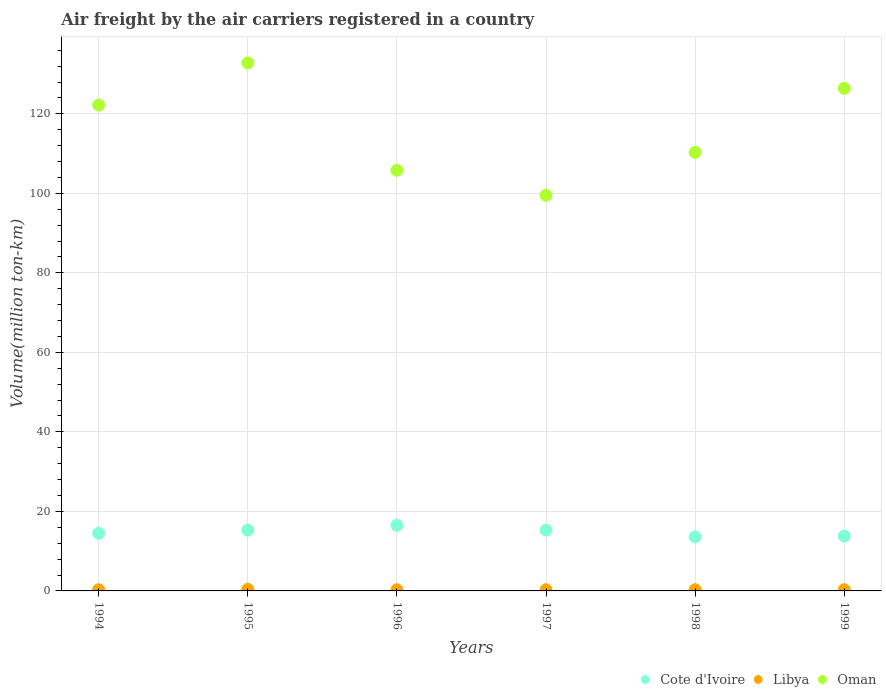Is the number of dotlines equal to the number of legend labels?
Your response must be concise. Yes. What is the volume of the air carriers in Oman in 1995?
Make the answer very short. 132.8. Across all years, what is the minimum volume of the air carriers in Oman?
Ensure brevity in your answer.  99.5. In which year was the volume of the air carriers in Libya maximum?
Your answer should be very brief. 1995. What is the total volume of the air carriers in Libya in the graph?
Give a very brief answer. 1.9. What is the difference between the volume of the air carriers in Cote d'Ivoire in 1994 and the volume of the air carriers in Libya in 1999?
Give a very brief answer. 14.2. What is the average volume of the air carriers in Cote d'Ivoire per year?
Your answer should be compact. 14.83. In the year 1998, what is the difference between the volume of the air carriers in Libya and volume of the air carriers in Cote d'Ivoire?
Ensure brevity in your answer.  -13.3. In how many years, is the volume of the air carriers in Libya greater than 92 million ton-km?
Give a very brief answer. 0. What is the ratio of the volume of the air carriers in Cote d'Ivoire in 1997 to that in 1998?
Your answer should be very brief. 1.12. Is the difference between the volume of the air carriers in Libya in 1995 and 1999 greater than the difference between the volume of the air carriers in Cote d'Ivoire in 1995 and 1999?
Offer a very short reply. No. What is the difference between the highest and the second highest volume of the air carriers in Libya?
Your answer should be compact. 0.1. What is the difference between the highest and the lowest volume of the air carriers in Libya?
Keep it short and to the point. 0.1. Is the sum of the volume of the air carriers in Oman in 1995 and 1998 greater than the maximum volume of the air carriers in Libya across all years?
Your response must be concise. Yes. Is it the case that in every year, the sum of the volume of the air carriers in Oman and volume of the air carriers in Cote d'Ivoire  is greater than the volume of the air carriers in Libya?
Provide a succinct answer. Yes. Is the volume of the air carriers in Cote d'Ivoire strictly greater than the volume of the air carriers in Libya over the years?
Offer a terse response. Yes. Is the volume of the air carriers in Libya strictly less than the volume of the air carriers in Oman over the years?
Your answer should be very brief. Yes. How many years are there in the graph?
Provide a short and direct response. 6. What is the difference between two consecutive major ticks on the Y-axis?
Your answer should be compact. 20. Does the graph contain any zero values?
Your answer should be compact. No. Does the graph contain grids?
Provide a short and direct response. Yes. Where does the legend appear in the graph?
Provide a succinct answer. Bottom right. How are the legend labels stacked?
Keep it short and to the point. Horizontal. What is the title of the graph?
Offer a terse response. Air freight by the air carriers registered in a country. What is the label or title of the X-axis?
Make the answer very short. Years. What is the label or title of the Y-axis?
Your answer should be very brief. Volume(million ton-km). What is the Volume(million ton-km) in Cote d'Ivoire in 1994?
Ensure brevity in your answer.  14.5. What is the Volume(million ton-km) of Libya in 1994?
Provide a succinct answer. 0.3. What is the Volume(million ton-km) of Oman in 1994?
Ensure brevity in your answer.  122.2. What is the Volume(million ton-km) of Cote d'Ivoire in 1995?
Your answer should be compact. 15.3. What is the Volume(million ton-km) in Libya in 1995?
Offer a very short reply. 0.4. What is the Volume(million ton-km) in Oman in 1995?
Ensure brevity in your answer.  132.8. What is the Volume(million ton-km) of Libya in 1996?
Your response must be concise. 0.3. What is the Volume(million ton-km) of Oman in 1996?
Your answer should be compact. 105.8. What is the Volume(million ton-km) of Cote d'Ivoire in 1997?
Offer a very short reply. 15.3. What is the Volume(million ton-km) of Libya in 1997?
Offer a terse response. 0.3. What is the Volume(million ton-km) of Oman in 1997?
Make the answer very short. 99.5. What is the Volume(million ton-km) of Cote d'Ivoire in 1998?
Your answer should be compact. 13.6. What is the Volume(million ton-km) of Libya in 1998?
Provide a succinct answer. 0.3. What is the Volume(million ton-km) in Oman in 1998?
Offer a very short reply. 110.3. What is the Volume(million ton-km) in Cote d'Ivoire in 1999?
Offer a very short reply. 13.8. What is the Volume(million ton-km) of Libya in 1999?
Your response must be concise. 0.3. What is the Volume(million ton-km) in Oman in 1999?
Make the answer very short. 126.4. Across all years, what is the maximum Volume(million ton-km) of Libya?
Your answer should be compact. 0.4. Across all years, what is the maximum Volume(million ton-km) in Oman?
Offer a very short reply. 132.8. Across all years, what is the minimum Volume(million ton-km) of Cote d'Ivoire?
Ensure brevity in your answer.  13.6. Across all years, what is the minimum Volume(million ton-km) in Libya?
Your answer should be very brief. 0.3. Across all years, what is the minimum Volume(million ton-km) of Oman?
Your response must be concise. 99.5. What is the total Volume(million ton-km) of Cote d'Ivoire in the graph?
Provide a succinct answer. 89. What is the total Volume(million ton-km) in Oman in the graph?
Provide a short and direct response. 697. What is the difference between the Volume(million ton-km) of Cote d'Ivoire in 1994 and that in 1995?
Ensure brevity in your answer.  -0.8. What is the difference between the Volume(million ton-km) of Libya in 1994 and that in 1995?
Make the answer very short. -0.1. What is the difference between the Volume(million ton-km) of Oman in 1994 and that in 1995?
Your response must be concise. -10.6. What is the difference between the Volume(million ton-km) in Libya in 1994 and that in 1996?
Give a very brief answer. 0. What is the difference between the Volume(million ton-km) in Oman in 1994 and that in 1996?
Your answer should be very brief. 16.4. What is the difference between the Volume(million ton-km) of Cote d'Ivoire in 1994 and that in 1997?
Offer a terse response. -0.8. What is the difference between the Volume(million ton-km) of Libya in 1994 and that in 1997?
Give a very brief answer. 0. What is the difference between the Volume(million ton-km) in Oman in 1994 and that in 1997?
Keep it short and to the point. 22.7. What is the difference between the Volume(million ton-km) in Oman in 1994 and that in 1998?
Give a very brief answer. 11.9. What is the difference between the Volume(million ton-km) in Cote d'Ivoire in 1994 and that in 1999?
Your response must be concise. 0.7. What is the difference between the Volume(million ton-km) in Oman in 1994 and that in 1999?
Make the answer very short. -4.2. What is the difference between the Volume(million ton-km) of Libya in 1995 and that in 1996?
Ensure brevity in your answer.  0.1. What is the difference between the Volume(million ton-km) in Libya in 1995 and that in 1997?
Offer a terse response. 0.1. What is the difference between the Volume(million ton-km) in Oman in 1995 and that in 1997?
Offer a very short reply. 33.3. What is the difference between the Volume(million ton-km) of Oman in 1995 and that in 1998?
Offer a very short reply. 22.5. What is the difference between the Volume(million ton-km) in Cote d'Ivoire in 1995 and that in 1999?
Your answer should be compact. 1.5. What is the difference between the Volume(million ton-km) in Libya in 1996 and that in 1997?
Your answer should be compact. 0. What is the difference between the Volume(million ton-km) in Libya in 1996 and that in 1998?
Your answer should be very brief. 0. What is the difference between the Volume(million ton-km) of Oman in 1996 and that in 1998?
Offer a very short reply. -4.5. What is the difference between the Volume(million ton-km) in Libya in 1996 and that in 1999?
Your answer should be compact. 0. What is the difference between the Volume(million ton-km) in Oman in 1996 and that in 1999?
Provide a succinct answer. -20.6. What is the difference between the Volume(million ton-km) in Oman in 1997 and that in 1998?
Keep it short and to the point. -10.8. What is the difference between the Volume(million ton-km) of Cote d'Ivoire in 1997 and that in 1999?
Your response must be concise. 1.5. What is the difference between the Volume(million ton-km) of Oman in 1997 and that in 1999?
Your response must be concise. -26.9. What is the difference between the Volume(million ton-km) in Cote d'Ivoire in 1998 and that in 1999?
Provide a short and direct response. -0.2. What is the difference between the Volume(million ton-km) of Libya in 1998 and that in 1999?
Provide a short and direct response. 0. What is the difference between the Volume(million ton-km) of Oman in 1998 and that in 1999?
Keep it short and to the point. -16.1. What is the difference between the Volume(million ton-km) in Cote d'Ivoire in 1994 and the Volume(million ton-km) in Oman in 1995?
Give a very brief answer. -118.3. What is the difference between the Volume(million ton-km) in Libya in 1994 and the Volume(million ton-km) in Oman in 1995?
Offer a very short reply. -132.5. What is the difference between the Volume(million ton-km) of Cote d'Ivoire in 1994 and the Volume(million ton-km) of Oman in 1996?
Offer a very short reply. -91.3. What is the difference between the Volume(million ton-km) of Libya in 1994 and the Volume(million ton-km) of Oman in 1996?
Give a very brief answer. -105.5. What is the difference between the Volume(million ton-km) of Cote d'Ivoire in 1994 and the Volume(million ton-km) of Oman in 1997?
Provide a short and direct response. -85. What is the difference between the Volume(million ton-km) in Libya in 1994 and the Volume(million ton-km) in Oman in 1997?
Give a very brief answer. -99.2. What is the difference between the Volume(million ton-km) in Cote d'Ivoire in 1994 and the Volume(million ton-km) in Oman in 1998?
Ensure brevity in your answer.  -95.8. What is the difference between the Volume(million ton-km) in Libya in 1994 and the Volume(million ton-km) in Oman in 1998?
Offer a very short reply. -110. What is the difference between the Volume(million ton-km) of Cote d'Ivoire in 1994 and the Volume(million ton-km) of Libya in 1999?
Your answer should be very brief. 14.2. What is the difference between the Volume(million ton-km) of Cote d'Ivoire in 1994 and the Volume(million ton-km) of Oman in 1999?
Offer a very short reply. -111.9. What is the difference between the Volume(million ton-km) of Libya in 1994 and the Volume(million ton-km) of Oman in 1999?
Your answer should be very brief. -126.1. What is the difference between the Volume(million ton-km) in Cote d'Ivoire in 1995 and the Volume(million ton-km) in Libya in 1996?
Make the answer very short. 15. What is the difference between the Volume(million ton-km) of Cote d'Ivoire in 1995 and the Volume(million ton-km) of Oman in 1996?
Provide a short and direct response. -90.5. What is the difference between the Volume(million ton-km) of Libya in 1995 and the Volume(million ton-km) of Oman in 1996?
Your response must be concise. -105.4. What is the difference between the Volume(million ton-km) in Cote d'Ivoire in 1995 and the Volume(million ton-km) in Libya in 1997?
Give a very brief answer. 15. What is the difference between the Volume(million ton-km) of Cote d'Ivoire in 1995 and the Volume(million ton-km) of Oman in 1997?
Give a very brief answer. -84.2. What is the difference between the Volume(million ton-km) of Libya in 1995 and the Volume(million ton-km) of Oman in 1997?
Offer a very short reply. -99.1. What is the difference between the Volume(million ton-km) of Cote d'Ivoire in 1995 and the Volume(million ton-km) of Libya in 1998?
Ensure brevity in your answer.  15. What is the difference between the Volume(million ton-km) of Cote d'Ivoire in 1995 and the Volume(million ton-km) of Oman in 1998?
Ensure brevity in your answer.  -95. What is the difference between the Volume(million ton-km) in Libya in 1995 and the Volume(million ton-km) in Oman in 1998?
Your answer should be compact. -109.9. What is the difference between the Volume(million ton-km) of Cote d'Ivoire in 1995 and the Volume(million ton-km) of Oman in 1999?
Ensure brevity in your answer.  -111.1. What is the difference between the Volume(million ton-km) in Libya in 1995 and the Volume(million ton-km) in Oman in 1999?
Give a very brief answer. -126. What is the difference between the Volume(million ton-km) in Cote d'Ivoire in 1996 and the Volume(million ton-km) in Oman in 1997?
Your response must be concise. -83. What is the difference between the Volume(million ton-km) of Libya in 1996 and the Volume(million ton-km) of Oman in 1997?
Offer a terse response. -99.2. What is the difference between the Volume(million ton-km) of Cote d'Ivoire in 1996 and the Volume(million ton-km) of Libya in 1998?
Your answer should be very brief. 16.2. What is the difference between the Volume(million ton-km) in Cote d'Ivoire in 1996 and the Volume(million ton-km) in Oman in 1998?
Your answer should be very brief. -93.8. What is the difference between the Volume(million ton-km) in Libya in 1996 and the Volume(million ton-km) in Oman in 1998?
Ensure brevity in your answer.  -110. What is the difference between the Volume(million ton-km) of Cote d'Ivoire in 1996 and the Volume(million ton-km) of Oman in 1999?
Make the answer very short. -109.9. What is the difference between the Volume(million ton-km) in Libya in 1996 and the Volume(million ton-km) in Oman in 1999?
Your answer should be compact. -126.1. What is the difference between the Volume(million ton-km) in Cote d'Ivoire in 1997 and the Volume(million ton-km) in Oman in 1998?
Ensure brevity in your answer.  -95. What is the difference between the Volume(million ton-km) of Libya in 1997 and the Volume(million ton-km) of Oman in 1998?
Ensure brevity in your answer.  -110. What is the difference between the Volume(million ton-km) of Cote d'Ivoire in 1997 and the Volume(million ton-km) of Libya in 1999?
Offer a very short reply. 15. What is the difference between the Volume(million ton-km) in Cote d'Ivoire in 1997 and the Volume(million ton-km) in Oman in 1999?
Your response must be concise. -111.1. What is the difference between the Volume(million ton-km) of Libya in 1997 and the Volume(million ton-km) of Oman in 1999?
Provide a short and direct response. -126.1. What is the difference between the Volume(million ton-km) in Cote d'Ivoire in 1998 and the Volume(million ton-km) in Oman in 1999?
Your response must be concise. -112.8. What is the difference between the Volume(million ton-km) in Libya in 1998 and the Volume(million ton-km) in Oman in 1999?
Provide a short and direct response. -126.1. What is the average Volume(million ton-km) in Cote d'Ivoire per year?
Provide a short and direct response. 14.83. What is the average Volume(million ton-km) of Libya per year?
Provide a short and direct response. 0.32. What is the average Volume(million ton-km) in Oman per year?
Give a very brief answer. 116.17. In the year 1994, what is the difference between the Volume(million ton-km) in Cote d'Ivoire and Volume(million ton-km) in Oman?
Offer a terse response. -107.7. In the year 1994, what is the difference between the Volume(million ton-km) in Libya and Volume(million ton-km) in Oman?
Make the answer very short. -121.9. In the year 1995, what is the difference between the Volume(million ton-km) of Cote d'Ivoire and Volume(million ton-km) of Libya?
Make the answer very short. 14.9. In the year 1995, what is the difference between the Volume(million ton-km) in Cote d'Ivoire and Volume(million ton-km) in Oman?
Your response must be concise. -117.5. In the year 1995, what is the difference between the Volume(million ton-km) in Libya and Volume(million ton-km) in Oman?
Keep it short and to the point. -132.4. In the year 1996, what is the difference between the Volume(million ton-km) in Cote d'Ivoire and Volume(million ton-km) in Libya?
Ensure brevity in your answer.  16.2. In the year 1996, what is the difference between the Volume(million ton-km) of Cote d'Ivoire and Volume(million ton-km) of Oman?
Give a very brief answer. -89.3. In the year 1996, what is the difference between the Volume(million ton-km) in Libya and Volume(million ton-km) in Oman?
Your answer should be very brief. -105.5. In the year 1997, what is the difference between the Volume(million ton-km) in Cote d'Ivoire and Volume(million ton-km) in Oman?
Keep it short and to the point. -84.2. In the year 1997, what is the difference between the Volume(million ton-km) of Libya and Volume(million ton-km) of Oman?
Provide a succinct answer. -99.2. In the year 1998, what is the difference between the Volume(million ton-km) of Cote d'Ivoire and Volume(million ton-km) of Libya?
Provide a short and direct response. 13.3. In the year 1998, what is the difference between the Volume(million ton-km) in Cote d'Ivoire and Volume(million ton-km) in Oman?
Offer a very short reply. -96.7. In the year 1998, what is the difference between the Volume(million ton-km) of Libya and Volume(million ton-km) of Oman?
Give a very brief answer. -110. In the year 1999, what is the difference between the Volume(million ton-km) of Cote d'Ivoire and Volume(million ton-km) of Oman?
Your response must be concise. -112.6. In the year 1999, what is the difference between the Volume(million ton-km) of Libya and Volume(million ton-km) of Oman?
Make the answer very short. -126.1. What is the ratio of the Volume(million ton-km) of Cote d'Ivoire in 1994 to that in 1995?
Your answer should be compact. 0.95. What is the ratio of the Volume(million ton-km) in Libya in 1994 to that in 1995?
Your response must be concise. 0.75. What is the ratio of the Volume(million ton-km) of Oman in 1994 to that in 1995?
Offer a terse response. 0.92. What is the ratio of the Volume(million ton-km) of Cote d'Ivoire in 1994 to that in 1996?
Provide a succinct answer. 0.88. What is the ratio of the Volume(million ton-km) in Libya in 1994 to that in 1996?
Give a very brief answer. 1. What is the ratio of the Volume(million ton-km) in Oman in 1994 to that in 1996?
Your answer should be compact. 1.16. What is the ratio of the Volume(million ton-km) in Cote d'Ivoire in 1994 to that in 1997?
Make the answer very short. 0.95. What is the ratio of the Volume(million ton-km) in Oman in 1994 to that in 1997?
Offer a terse response. 1.23. What is the ratio of the Volume(million ton-km) in Cote d'Ivoire in 1994 to that in 1998?
Offer a terse response. 1.07. What is the ratio of the Volume(million ton-km) of Libya in 1994 to that in 1998?
Offer a very short reply. 1. What is the ratio of the Volume(million ton-km) in Oman in 1994 to that in 1998?
Provide a short and direct response. 1.11. What is the ratio of the Volume(million ton-km) in Cote d'Ivoire in 1994 to that in 1999?
Provide a succinct answer. 1.05. What is the ratio of the Volume(million ton-km) of Oman in 1994 to that in 1999?
Your answer should be compact. 0.97. What is the ratio of the Volume(million ton-km) in Cote d'Ivoire in 1995 to that in 1996?
Your answer should be very brief. 0.93. What is the ratio of the Volume(million ton-km) of Libya in 1995 to that in 1996?
Your response must be concise. 1.33. What is the ratio of the Volume(million ton-km) of Oman in 1995 to that in 1996?
Provide a short and direct response. 1.26. What is the ratio of the Volume(million ton-km) of Cote d'Ivoire in 1995 to that in 1997?
Provide a short and direct response. 1. What is the ratio of the Volume(million ton-km) in Libya in 1995 to that in 1997?
Your answer should be very brief. 1.33. What is the ratio of the Volume(million ton-km) of Oman in 1995 to that in 1997?
Provide a succinct answer. 1.33. What is the ratio of the Volume(million ton-km) in Libya in 1995 to that in 1998?
Offer a very short reply. 1.33. What is the ratio of the Volume(million ton-km) of Oman in 1995 to that in 1998?
Your answer should be very brief. 1.2. What is the ratio of the Volume(million ton-km) in Cote d'Ivoire in 1995 to that in 1999?
Give a very brief answer. 1.11. What is the ratio of the Volume(million ton-km) of Oman in 1995 to that in 1999?
Give a very brief answer. 1.05. What is the ratio of the Volume(million ton-km) in Cote d'Ivoire in 1996 to that in 1997?
Ensure brevity in your answer.  1.08. What is the ratio of the Volume(million ton-km) of Oman in 1996 to that in 1997?
Make the answer very short. 1.06. What is the ratio of the Volume(million ton-km) of Cote d'Ivoire in 1996 to that in 1998?
Your answer should be compact. 1.21. What is the ratio of the Volume(million ton-km) in Oman in 1996 to that in 1998?
Ensure brevity in your answer.  0.96. What is the ratio of the Volume(million ton-km) in Cote d'Ivoire in 1996 to that in 1999?
Offer a very short reply. 1.2. What is the ratio of the Volume(million ton-km) in Oman in 1996 to that in 1999?
Offer a terse response. 0.84. What is the ratio of the Volume(million ton-km) in Cote d'Ivoire in 1997 to that in 1998?
Offer a terse response. 1.12. What is the ratio of the Volume(million ton-km) of Oman in 1997 to that in 1998?
Give a very brief answer. 0.9. What is the ratio of the Volume(million ton-km) in Cote d'Ivoire in 1997 to that in 1999?
Make the answer very short. 1.11. What is the ratio of the Volume(million ton-km) of Libya in 1997 to that in 1999?
Your answer should be very brief. 1. What is the ratio of the Volume(million ton-km) in Oman in 1997 to that in 1999?
Your response must be concise. 0.79. What is the ratio of the Volume(million ton-km) of Cote d'Ivoire in 1998 to that in 1999?
Give a very brief answer. 0.99. What is the ratio of the Volume(million ton-km) of Oman in 1998 to that in 1999?
Give a very brief answer. 0.87. What is the difference between the highest and the second highest Volume(million ton-km) in Cote d'Ivoire?
Make the answer very short. 1.2. What is the difference between the highest and the second highest Volume(million ton-km) of Oman?
Provide a short and direct response. 6.4. What is the difference between the highest and the lowest Volume(million ton-km) of Cote d'Ivoire?
Make the answer very short. 2.9. What is the difference between the highest and the lowest Volume(million ton-km) of Libya?
Offer a very short reply. 0.1. What is the difference between the highest and the lowest Volume(million ton-km) of Oman?
Keep it short and to the point. 33.3. 